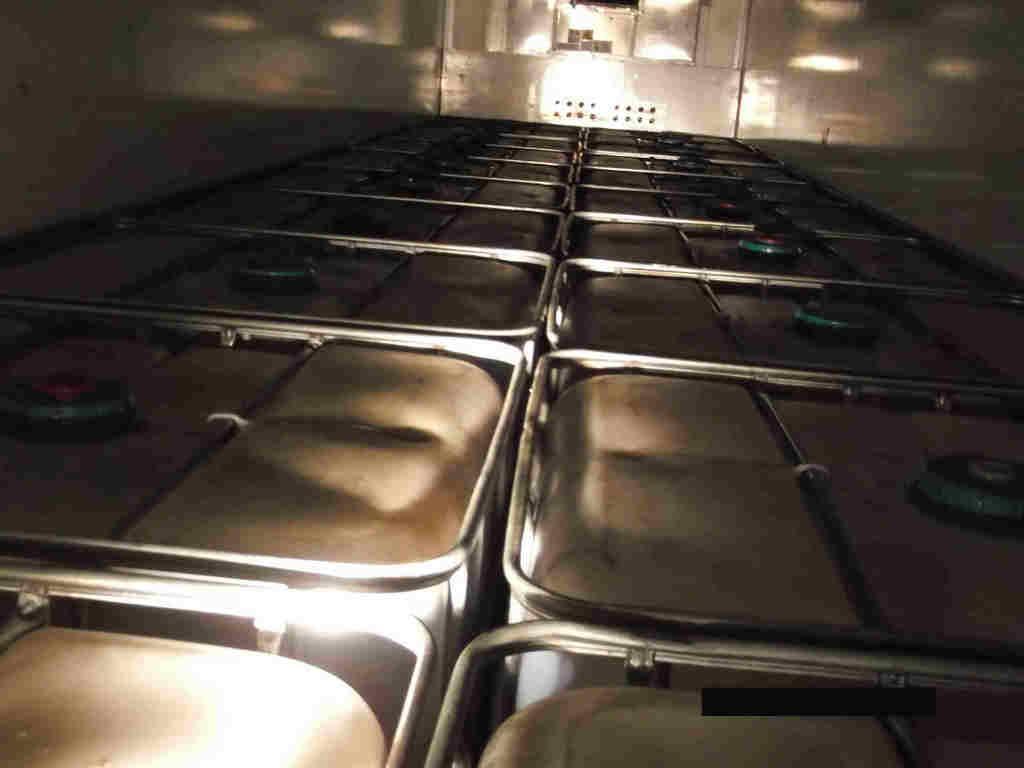Describe this image in one or two sentences. In this image there are many boxes. These are the walls. This is the light. 